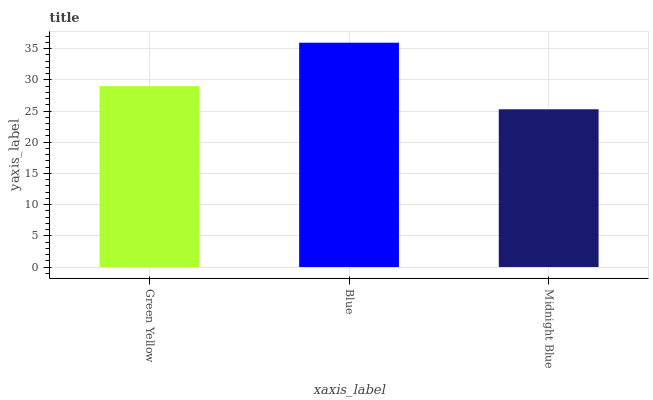Is Midnight Blue the minimum?
Answer yes or no. Yes. Is Blue the maximum?
Answer yes or no. Yes. Is Blue the minimum?
Answer yes or no. No. Is Midnight Blue the maximum?
Answer yes or no. No. Is Blue greater than Midnight Blue?
Answer yes or no. Yes. Is Midnight Blue less than Blue?
Answer yes or no. Yes. Is Midnight Blue greater than Blue?
Answer yes or no. No. Is Blue less than Midnight Blue?
Answer yes or no. No. Is Green Yellow the high median?
Answer yes or no. Yes. Is Green Yellow the low median?
Answer yes or no. Yes. Is Blue the high median?
Answer yes or no. No. Is Midnight Blue the low median?
Answer yes or no. No. 